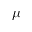Convert formula to latex. <formula><loc_0><loc_0><loc_500><loc_500>\mu</formula> 